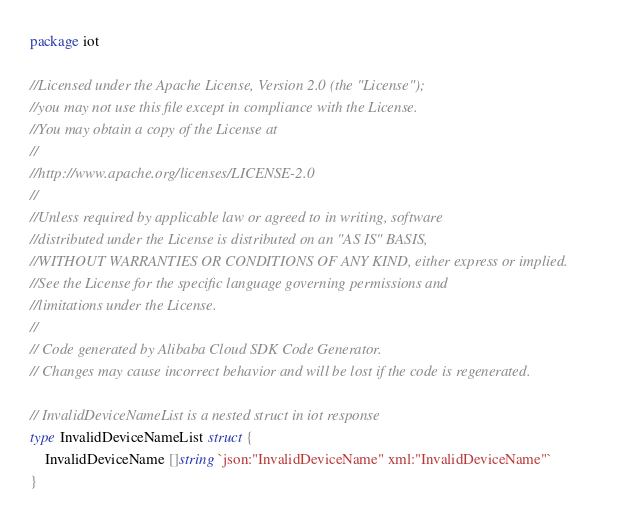Convert code to text. <code><loc_0><loc_0><loc_500><loc_500><_Go_>package iot

//Licensed under the Apache License, Version 2.0 (the "License");
//you may not use this file except in compliance with the License.
//You may obtain a copy of the License at
//
//http://www.apache.org/licenses/LICENSE-2.0
//
//Unless required by applicable law or agreed to in writing, software
//distributed under the License is distributed on an "AS IS" BASIS,
//WITHOUT WARRANTIES OR CONDITIONS OF ANY KIND, either express or implied.
//See the License for the specific language governing permissions and
//limitations under the License.
//
// Code generated by Alibaba Cloud SDK Code Generator.
// Changes may cause incorrect behavior and will be lost if the code is regenerated.

// InvalidDeviceNameList is a nested struct in iot response
type InvalidDeviceNameList struct {
	InvalidDeviceName []string `json:"InvalidDeviceName" xml:"InvalidDeviceName"`
}
</code> 